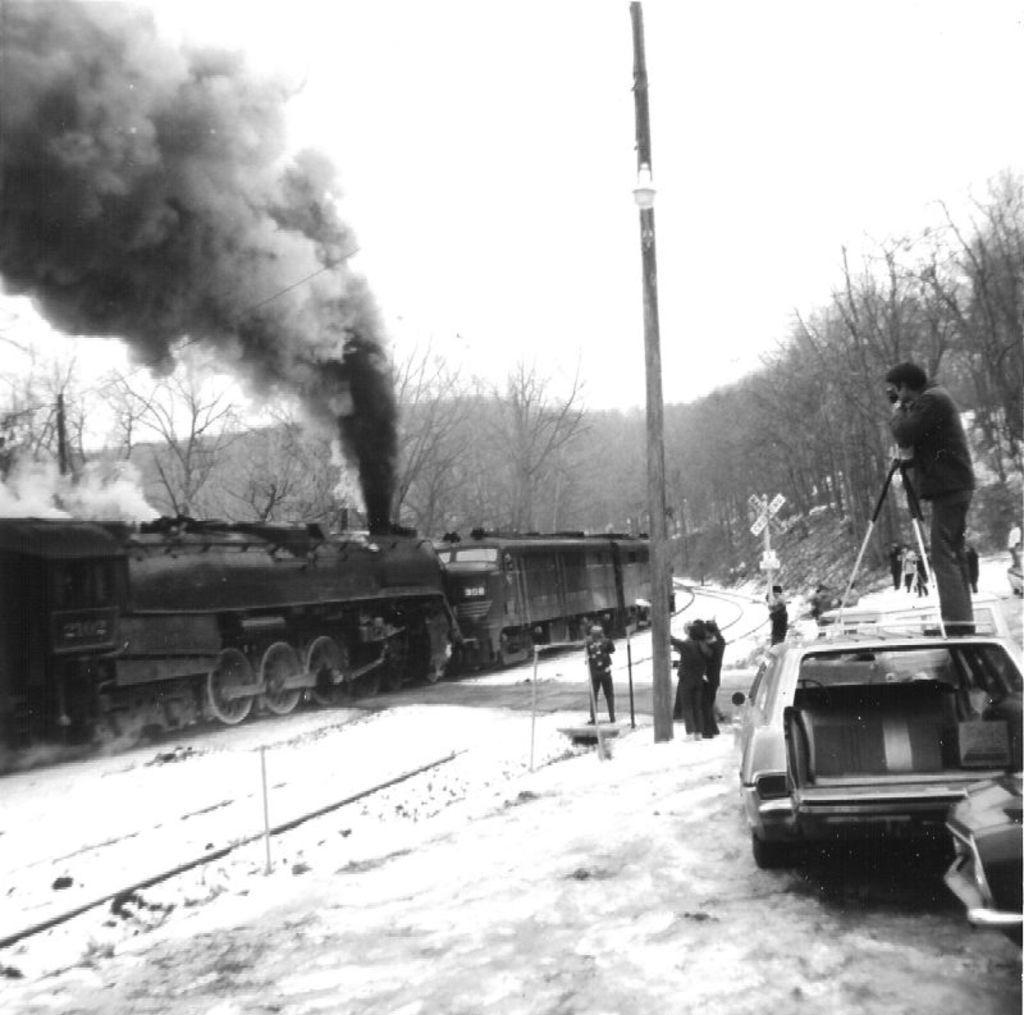How would you summarize this image in a sentence or two? In this black and white image, we can see some trees. There is a train on the left side of the image. There is a pole and some persons in the middle of the image. There is a person on the vehicle which is on the right side of the image. There is a sky at the top of the image. 